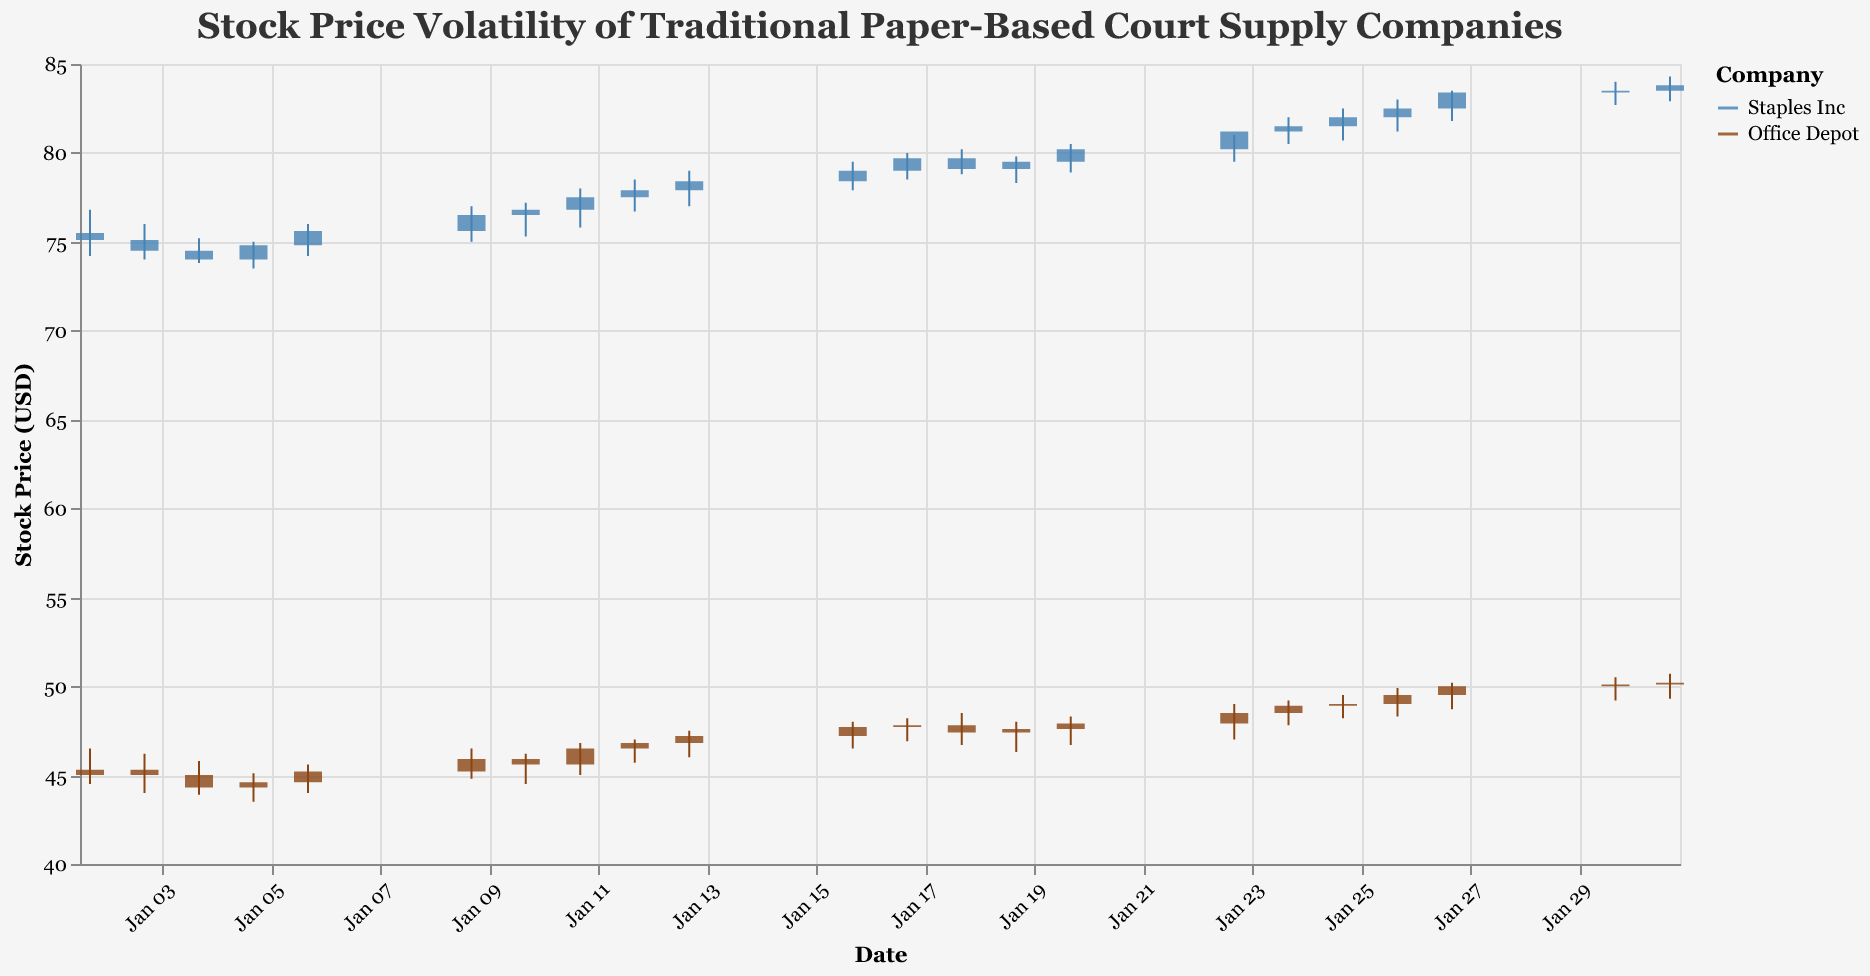How does the stock price tend to move within a day for both companies? By observing the candlestick patterns, we notice that each day is represented by a rectangle (the body) and lines (the wicks) extending from it. A green body means the stock closed higher than it opened, while a red body means it closed lower. Green represents increasing prices within the day, red represents decreasing prices. Both companies show a series of daily fluctuations captured in green and red.
Answer: Daily fluctuations with both gains and losses Which company had a higher stock price on January 15th? By checking the date labeled close to January 15th, there are no labels exactly for January 15th as it falls on a weekend, but we can approximate from the labels near this date (January 13th, and January 16th). On January 16th, Staples Inc closed at a higher price relative to Office Depot on the same date, confirming it from the y-axis scale for both labels.
Answer: Staples Inc Which company experienced higher overall growth in stock price during January 2023? Staples Inc went from an opening price of 75.50 on January 2nd to a closing price of 83.80 on January 31st. Office Depot went from an opening price of 45.00 to a closing price of 50.20 over the same period. Calculating the growth, Staples Inc's growth is 83.80 - 75.50 = 8.30, and Office Depot's growth is 50.20 - 45.00 = 5.20. Thus, comparing these values shows higher growth for Staples Inc.
Answer: Staples Inc What is the main trend seen for both companies during January 2023? By following the candlestick pattern throughout January 2023, both companies show a general upward trend over time. Staples Inc consistently shows increasing closing prices from the start to the end of the month, while Office Depot shows a similar pattern with a steady rise toward month-end.
Answer: Upward trend On which date did Staples Inc have the highest trading volume, and what was the price range on that day? Observing the volume bar heights, the highest trading volume for Staples Inc was on January 20th with a volume of 6,000,000. On this date, the price range (from Low to High) was from 78.90 to 80.50, observed from the candlestick.
Answer: January 20th, 78.90 to 80.50 